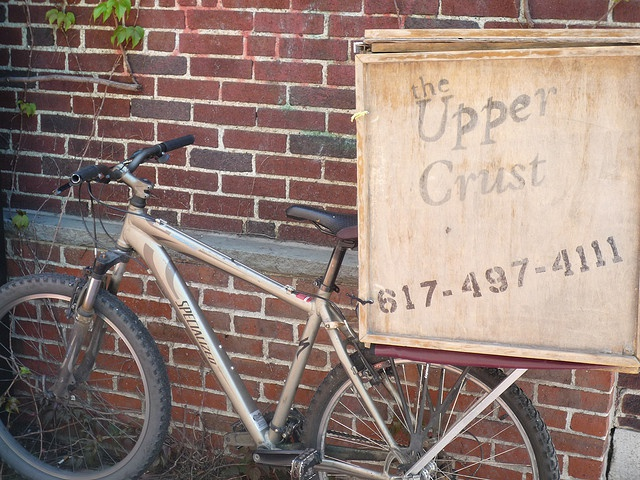Describe the objects in this image and their specific colors. I can see a bicycle in black, gray, and darkgray tones in this image. 